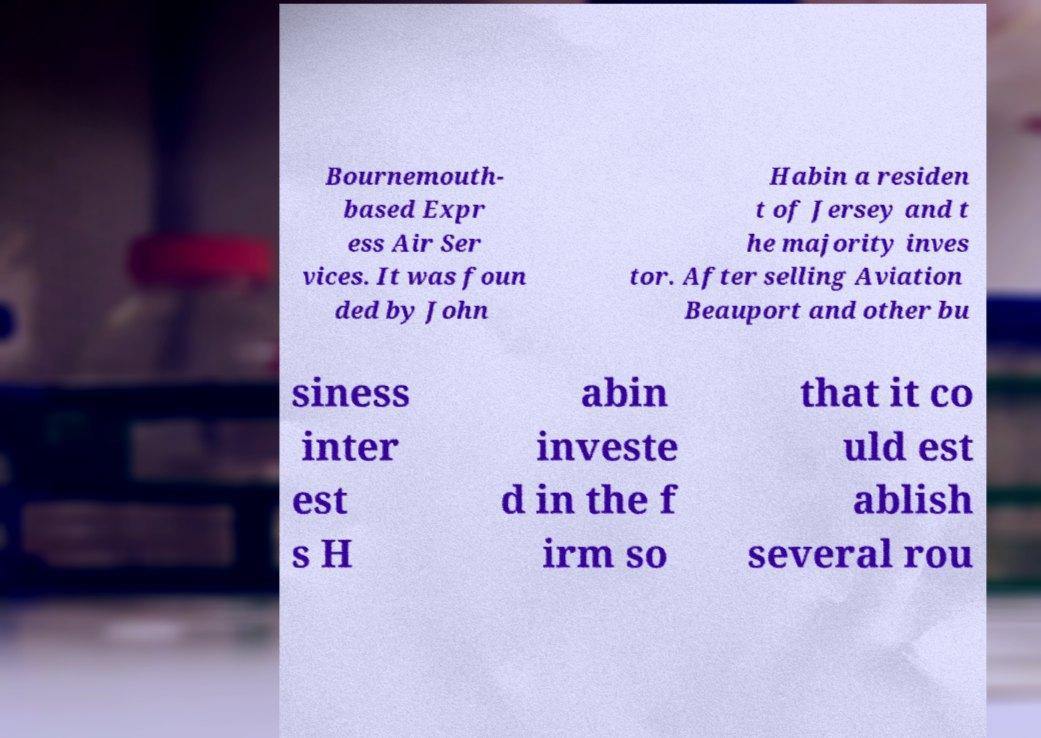Please read and relay the text visible in this image. What does it say? Bournemouth- based Expr ess Air Ser vices. It was foun ded by John Habin a residen t of Jersey and t he majority inves tor. After selling Aviation Beauport and other bu siness inter est s H abin investe d in the f irm so that it co uld est ablish several rou 